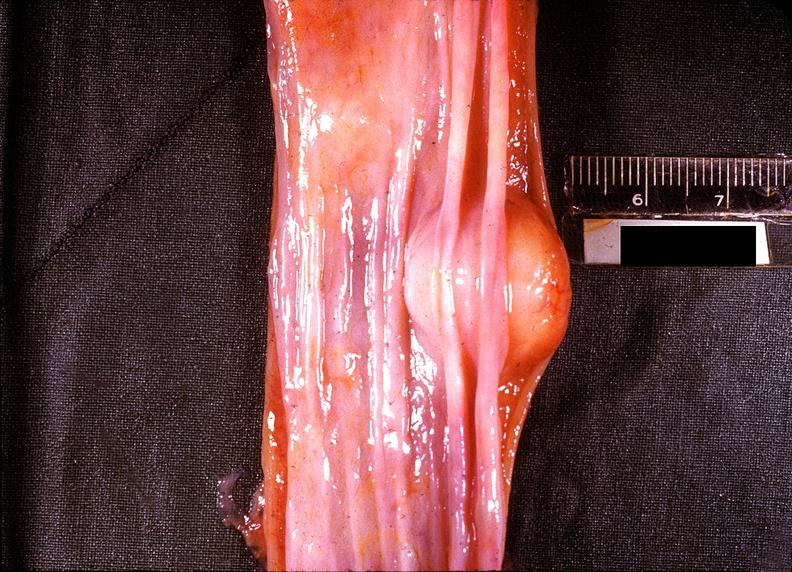what is present?
Answer the question using a single word or phrase. Gastrointestinal 